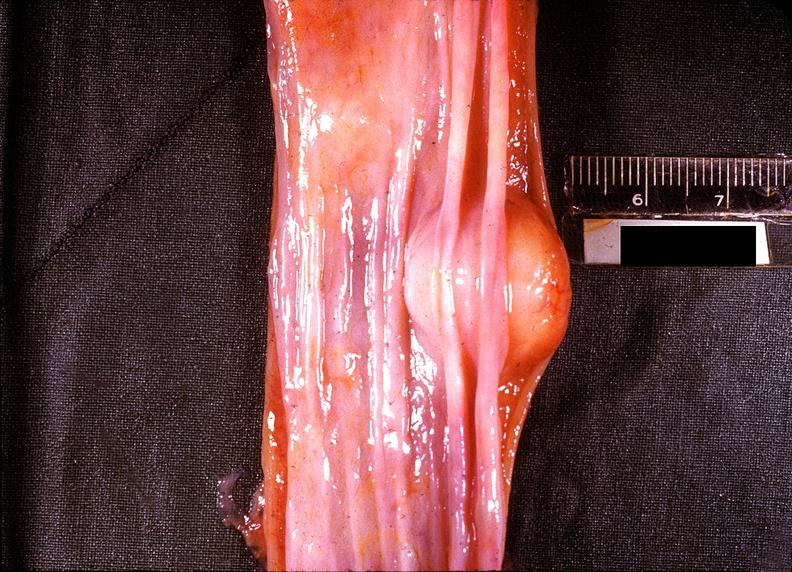what is present?
Answer the question using a single word or phrase. Gastrointestinal 